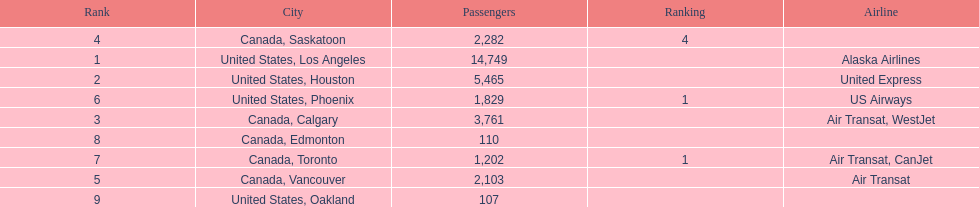Was los angeles or houston the busiest international route at manzanillo international airport in 2013? Los Angeles. 